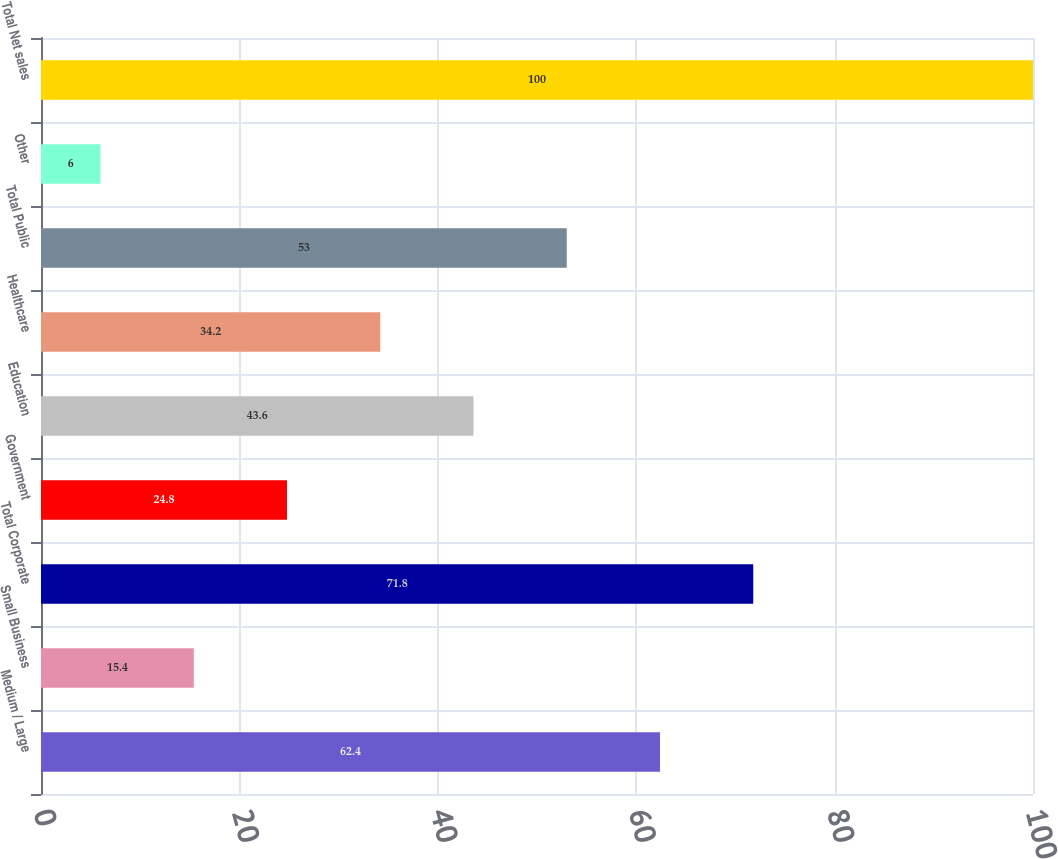Convert chart. <chart><loc_0><loc_0><loc_500><loc_500><bar_chart><fcel>Medium / Large<fcel>Small Business<fcel>Total Corporate<fcel>Government<fcel>Education<fcel>Healthcare<fcel>Total Public<fcel>Other<fcel>Total Net sales<nl><fcel>62.4<fcel>15.4<fcel>71.8<fcel>24.8<fcel>43.6<fcel>34.2<fcel>53<fcel>6<fcel>100<nl></chart> 